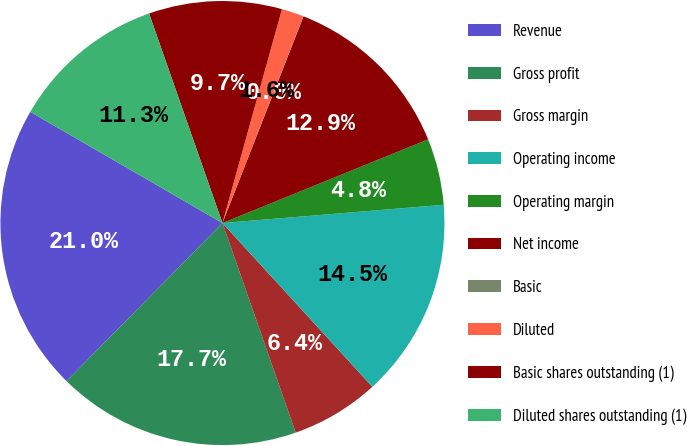Convert chart to OTSL. <chart><loc_0><loc_0><loc_500><loc_500><pie_chart><fcel>Revenue<fcel>Gross profit<fcel>Gross margin<fcel>Operating income<fcel>Operating margin<fcel>Net income<fcel>Basic<fcel>Diluted<fcel>Basic shares outstanding (1)<fcel>Diluted shares outstanding (1)<nl><fcel>20.96%<fcel>17.74%<fcel>6.45%<fcel>14.51%<fcel>4.84%<fcel>12.9%<fcel>0.01%<fcel>1.62%<fcel>9.68%<fcel>11.29%<nl></chart> 